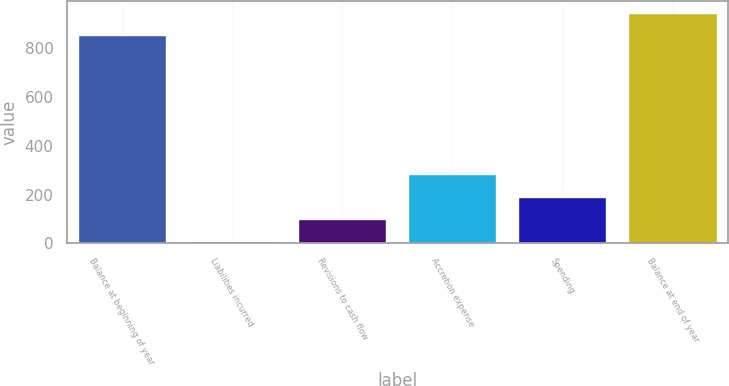Convert chart to OTSL. <chart><loc_0><loc_0><loc_500><loc_500><bar_chart><fcel>Balance at beginning of year<fcel>Liabilities incurred<fcel>Revisions to cash flow<fcel>Accretion expense<fcel>Spending<fcel>Balance at end of year<nl><fcel>856<fcel>9<fcel>100.2<fcel>282.6<fcel>191.4<fcel>947.2<nl></chart> 